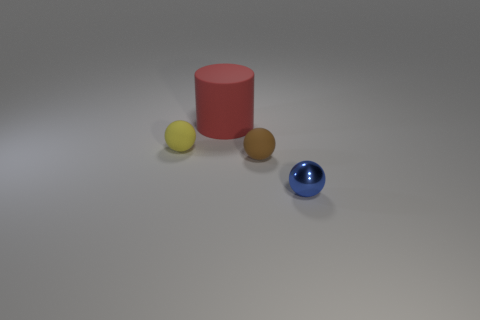Is there anything else that has the same material as the blue sphere?
Provide a short and direct response. No. Is there any other thing that is the same size as the red object?
Make the answer very short. No. Is the tiny yellow matte object the same shape as the blue metal thing?
Provide a succinct answer. Yes. Is there any other thing that is the same shape as the big red thing?
Your answer should be very brief. No. Is there a tiny brown metallic sphere?
Give a very brief answer. No. There is a brown object; is it the same shape as the tiny thing to the right of the small brown ball?
Your answer should be compact. Yes. What is the material of the small sphere behind the small rubber object on the right side of the large red matte thing?
Ensure brevity in your answer.  Rubber. What is the color of the large matte object?
Keep it short and to the point. Red. There is a yellow matte object that is the same shape as the blue metal thing; what size is it?
Provide a short and direct response. Small. How many tiny metallic balls have the same color as the large matte object?
Give a very brief answer. 0. 